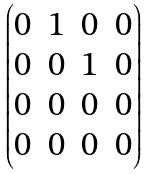<formula> <loc_0><loc_0><loc_500><loc_500>\begin{pmatrix} 0 & 1 & 0 & 0 \\ 0 & 0 & 1 & 0 \\ 0 & 0 & 0 & 0 \\ 0 & 0 & 0 & 0 \end{pmatrix}</formula> 